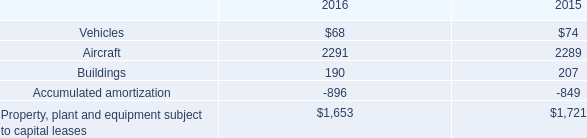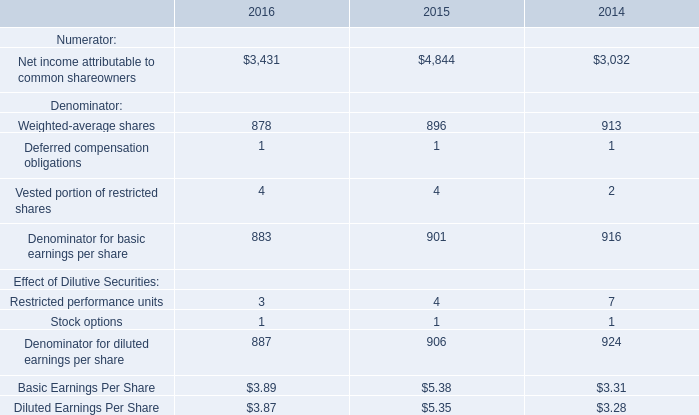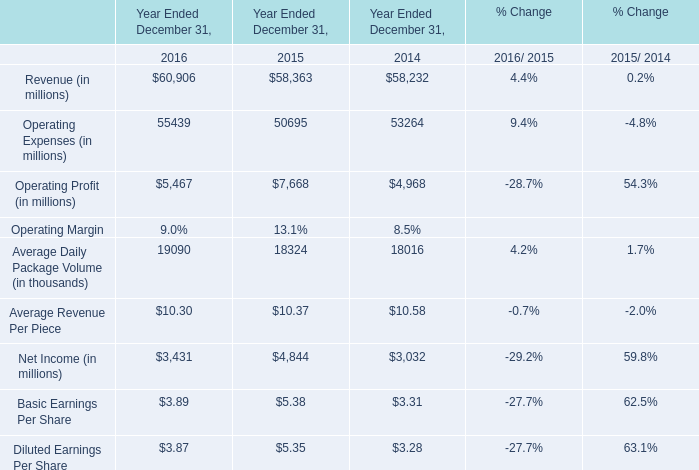What was the average of Average Daily Package Volume in 2016, 2015, and 2014 for Year Ended December 31,? (in thousand) 
Computations: (((19090 + 18324) + 18016) / 3)
Answer: 18476.66667. 